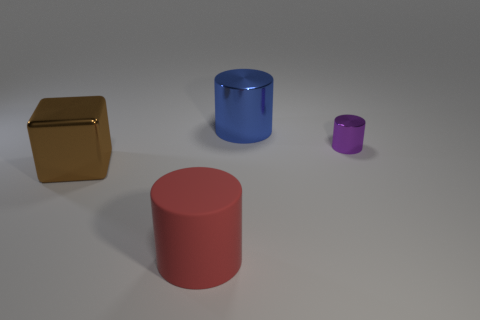What material is the purple object?
Provide a short and direct response. Metal. There is a brown thing that is made of the same material as the small purple cylinder; what shape is it?
Your answer should be compact. Cube. There is a shiny cylinder to the right of the large thing to the right of the big red matte cylinder; what size is it?
Provide a succinct answer. Small. There is a large cylinder in front of the big brown object; what is its color?
Provide a short and direct response. Red. Are there any other brown things of the same shape as the brown metallic thing?
Your answer should be very brief. No. Is the number of things that are behind the purple cylinder less than the number of blue metallic cylinders that are behind the brown cube?
Provide a succinct answer. No. The tiny metallic cylinder has what color?
Provide a succinct answer. Purple. There is a big shiny object that is to the right of the big brown shiny object; are there any tiny metal objects that are on the left side of it?
Your response must be concise. No. How many matte cylinders have the same size as the cube?
Make the answer very short. 1. There is a thing behind the shiny thing to the right of the large metallic cylinder; what number of red matte things are in front of it?
Offer a terse response. 1. 